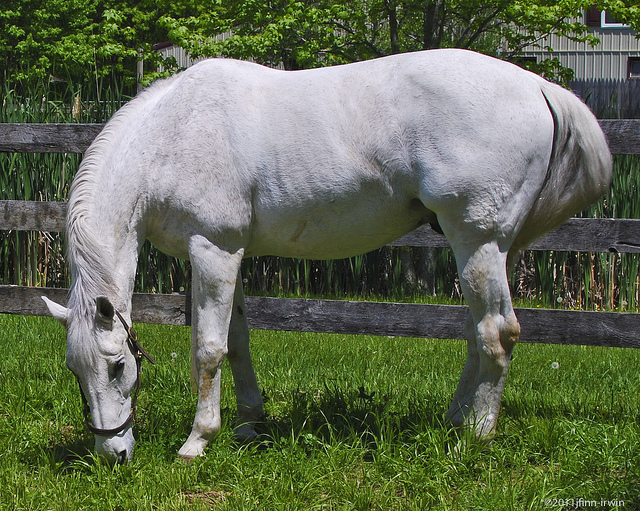Is there any other animal present in the image? No, there are no other animals present in the image besides the horse. 